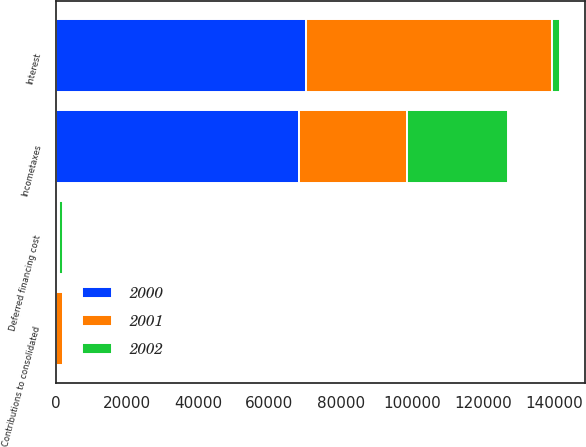Convert chart. <chart><loc_0><loc_0><loc_500><loc_500><stacked_bar_chart><ecel><fcel>Incometaxes<fcel>Interest<fcel>Contributions to consolidated<fcel>Deferred financing cost<nl><fcel>2001<fcel>30217<fcel>69114<fcel>2154<fcel>73<nl><fcel>2000<fcel>68264<fcel>70149<fcel>25<fcel>721<nl><fcel>2002<fcel>28585<fcel>2154<fcel>25<fcel>1192<nl></chart> 